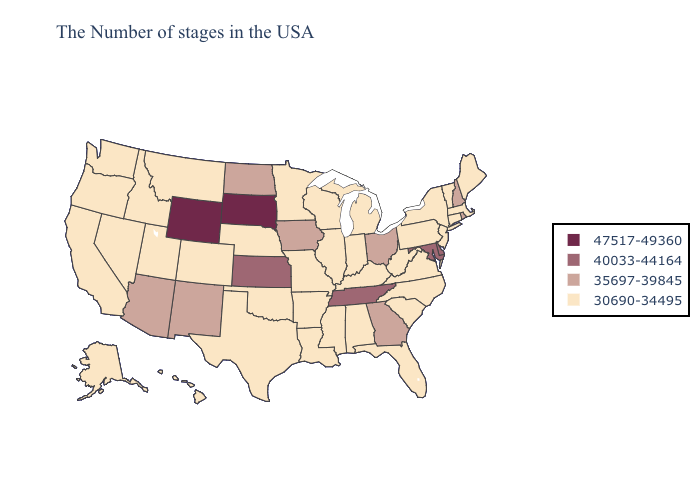Which states have the highest value in the USA?
Answer briefly. South Dakota, Wyoming. Does the map have missing data?
Short answer required. No. Name the states that have a value in the range 40033-44164?
Concise answer only. Delaware, Maryland, Tennessee, Kansas. Name the states that have a value in the range 47517-49360?
Give a very brief answer. South Dakota, Wyoming. Among the states that border Washington , which have the highest value?
Write a very short answer. Idaho, Oregon. Which states have the lowest value in the USA?
Keep it brief. Maine, Massachusetts, Vermont, Connecticut, New York, New Jersey, Pennsylvania, Virginia, North Carolina, South Carolina, West Virginia, Florida, Michigan, Kentucky, Indiana, Alabama, Wisconsin, Illinois, Mississippi, Louisiana, Missouri, Arkansas, Minnesota, Nebraska, Oklahoma, Texas, Colorado, Utah, Montana, Idaho, Nevada, California, Washington, Oregon, Alaska, Hawaii. Does the map have missing data?
Answer briefly. No. Name the states that have a value in the range 35697-39845?
Quick response, please. Rhode Island, New Hampshire, Ohio, Georgia, Iowa, North Dakota, New Mexico, Arizona. Does the first symbol in the legend represent the smallest category?
Concise answer only. No. What is the lowest value in the USA?
Give a very brief answer. 30690-34495. What is the highest value in the USA?
Short answer required. 47517-49360. What is the lowest value in the USA?
Be succinct. 30690-34495. Name the states that have a value in the range 35697-39845?
Keep it brief. Rhode Island, New Hampshire, Ohio, Georgia, Iowa, North Dakota, New Mexico, Arizona. Name the states that have a value in the range 35697-39845?
Write a very short answer. Rhode Island, New Hampshire, Ohio, Georgia, Iowa, North Dakota, New Mexico, Arizona. 